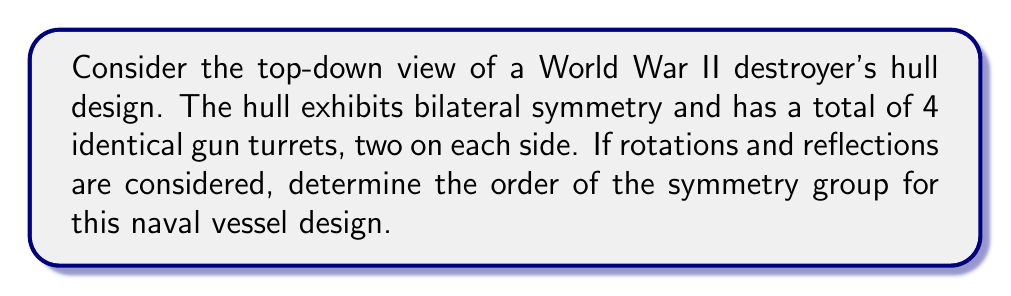Provide a solution to this math problem. To solve this problem, let's approach it step-by-step:

1) First, we need to identify the symmetries present in the design:
   - Bilateral symmetry (reflection across the longitudinal axis)
   - 180° rotation (which is equivalent to two reflections)

2) The symmetry group of this design is isomorphic to the cyclic group of order 2, $C_2$, or equivalently, to the symmetry group of a rectangle.

3) To determine the order of the symmetry group, we count the number of distinct symmetry operations:
   - Identity operation (leaving the ship unchanged)
   - Reflection across the longitudinal axis
   
4) The 180° rotation produces the same result as the reflection, so it doesn't count as a separate symmetry operation in this case.

5) Therefore, we have 2 distinct symmetry operations.

6) In group theory, the order of a group is the number of elements in the group. Here, each symmetry operation corresponds to one element of the group.

7) Thus, the order of the symmetry group is 2.

This group is isomorphic to $\mathbb{Z}_2$, the cyclic group of order 2, which can be represented as:

$$\{e, r\}$$

where $e$ is the identity element and $r$ is the reflection (or 180° rotation).
Answer: The order of the symmetry group for this naval vessel design is 2. 